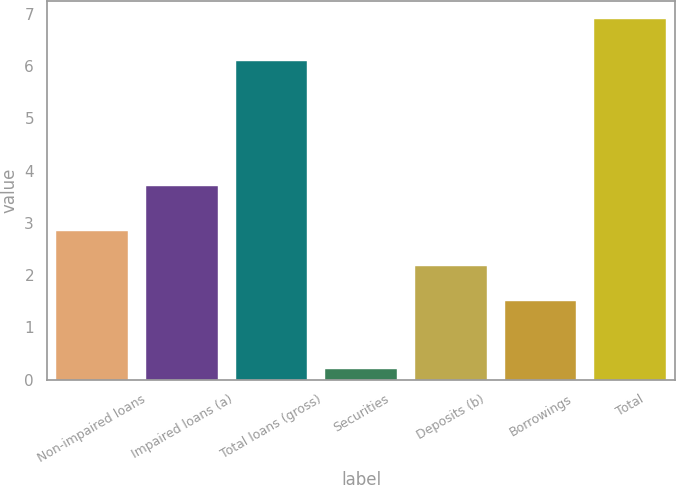<chart> <loc_0><loc_0><loc_500><loc_500><bar_chart><fcel>Non-impaired loans<fcel>Impaired loans (a)<fcel>Total loans (gross)<fcel>Securities<fcel>Deposits (b)<fcel>Borrowings<fcel>Total<nl><fcel>2.84<fcel>3.7<fcel>6.1<fcel>0.2<fcel>2.17<fcel>1.5<fcel>6.9<nl></chart> 